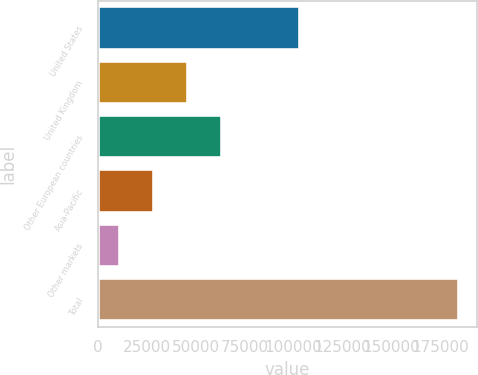<chart> <loc_0><loc_0><loc_500><loc_500><bar_chart><fcel>United States<fcel>United Kingdom<fcel>Other European countries<fcel>Asia-Pacific<fcel>Other markets<fcel>Total<nl><fcel>103043<fcel>45743.6<fcel>63098.9<fcel>28388.3<fcel>11033<fcel>184586<nl></chart> 